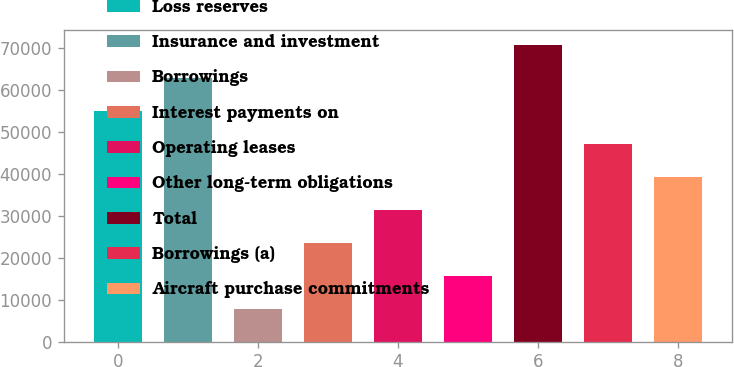Convert chart. <chart><loc_0><loc_0><loc_500><loc_500><bar_chart><fcel>Loss reserves<fcel>Insurance and investment<fcel>Borrowings<fcel>Interest payments on<fcel>Operating leases<fcel>Other long-term obligations<fcel>Total<fcel>Borrowings (a)<fcel>Aircraft purchase commitments<nl><fcel>54878.9<fcel>62716.6<fcel>7852.7<fcel>23528.1<fcel>31365.8<fcel>15690.4<fcel>70554.3<fcel>47041.2<fcel>39203.5<nl></chart> 